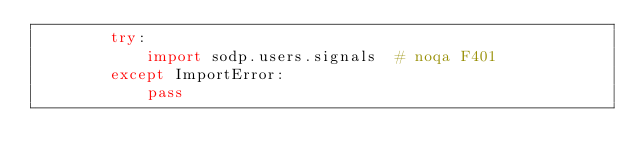Convert code to text. <code><loc_0><loc_0><loc_500><loc_500><_Python_>        try:
            import sodp.users.signals  # noqa F401
        except ImportError:
            pass
</code> 